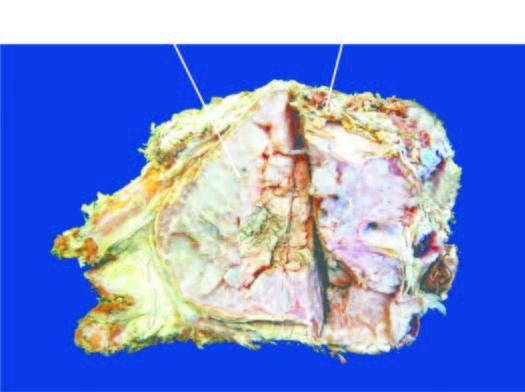what is expanded externally due to a gelatinous tumour?
Answer the question using a single word or phrase. Bone 